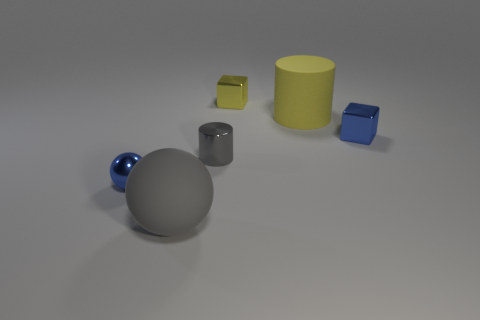What is the size of the yellow rubber thing that is the same shape as the tiny gray metal object?
Your answer should be very brief. Large. There is a blue object that is to the left of the matte thing that is to the right of the big gray ball; what is it made of?
Provide a short and direct response. Metal. What number of shiny things are tiny blue things or large cyan cubes?
Offer a terse response. 2. There is a matte object that is the same shape as the small gray shiny thing; what color is it?
Provide a short and direct response. Yellow. How many big rubber things have the same color as the tiny cylinder?
Make the answer very short. 1. Is there a big gray matte sphere that is in front of the blue metallic object behind the shiny cylinder?
Ensure brevity in your answer.  Yes. How many objects are to the left of the small gray thing and on the right side of the big yellow matte cylinder?
Give a very brief answer. 0. What number of cyan cylinders have the same material as the large yellow cylinder?
Give a very brief answer. 0. What size is the shiny cube that is behind the big thing that is behind the blue metallic sphere?
Offer a terse response. Small. Are there any large yellow things of the same shape as the tiny gray shiny thing?
Provide a short and direct response. Yes. 